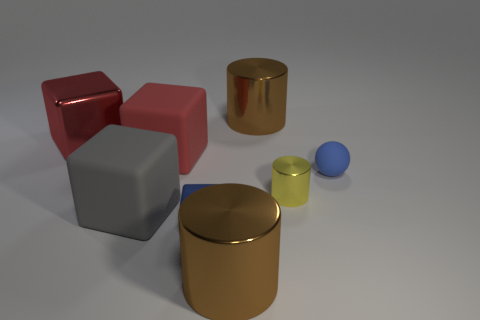Add 1 rubber balls. How many objects exist? 9 Subtract all spheres. How many objects are left? 7 Add 2 metal cubes. How many metal cubes exist? 4 Subtract 0 purple balls. How many objects are left? 8 Subtract all tiny shiny blocks. Subtract all big rubber cubes. How many objects are left? 5 Add 5 red shiny cubes. How many red shiny cubes are left? 6 